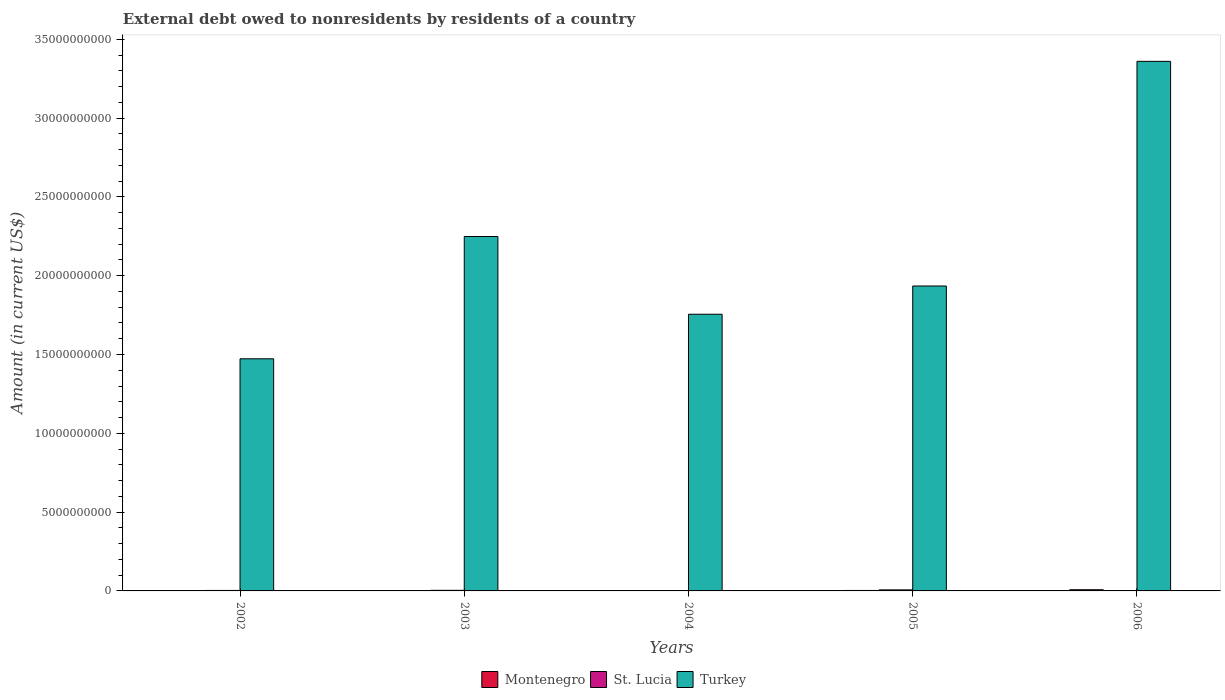How many different coloured bars are there?
Your answer should be compact. 3. How many groups of bars are there?
Offer a terse response. 5. What is the label of the 2nd group of bars from the left?
Make the answer very short. 2003. In how many cases, is the number of bars for a given year not equal to the number of legend labels?
Make the answer very short. 3. Across all years, what is the maximum external debt owed by residents in St. Lucia?
Make the answer very short. 6.54e+07. In which year was the external debt owed by residents in Turkey maximum?
Your response must be concise. 2006. What is the total external debt owed by residents in Montenegro in the graph?
Offer a terse response. 1.29e+08. What is the difference between the external debt owed by residents in St. Lucia in 2002 and that in 2003?
Provide a short and direct response. -7.80e+06. What is the difference between the external debt owed by residents in Montenegro in 2006 and the external debt owed by residents in Turkey in 2002?
Offer a terse response. -1.47e+1. What is the average external debt owed by residents in Montenegro per year?
Give a very brief answer. 2.58e+07. In the year 2004, what is the difference between the external debt owed by residents in St. Lucia and external debt owed by residents in Montenegro?
Provide a succinct answer. -4.16e+06. In how many years, is the external debt owed by residents in St. Lucia greater than 17000000000 US$?
Provide a short and direct response. 0. What is the ratio of the external debt owed by residents in Montenegro in 2004 to that in 2006?
Keep it short and to the point. 0.33. Is the external debt owed by residents in Montenegro in 2004 less than that in 2006?
Keep it short and to the point. Yes. What is the difference between the highest and the second highest external debt owed by residents in Montenegro?
Keep it short and to the point. 4.62e+07. What is the difference between the highest and the lowest external debt owed by residents in Montenegro?
Give a very brief answer. 7.52e+07. Is the sum of the external debt owed by residents in St. Lucia in 2002 and 2004 greater than the maximum external debt owed by residents in Montenegro across all years?
Offer a terse response. No. How many bars are there?
Your response must be concise. 12. How many years are there in the graph?
Provide a succinct answer. 5. What is the difference between two consecutive major ticks on the Y-axis?
Give a very brief answer. 5.00e+09. Are the values on the major ticks of Y-axis written in scientific E-notation?
Your answer should be compact. No. How are the legend labels stacked?
Offer a terse response. Horizontal. What is the title of the graph?
Keep it short and to the point. External debt owed to nonresidents by residents of a country. What is the Amount (in current US$) in St. Lucia in 2002?
Offer a very short reply. 3.02e+07. What is the Amount (in current US$) in Turkey in 2002?
Ensure brevity in your answer.  1.47e+1. What is the Amount (in current US$) of Montenegro in 2003?
Provide a short and direct response. 0. What is the Amount (in current US$) in St. Lucia in 2003?
Provide a short and direct response. 3.80e+07. What is the Amount (in current US$) in Turkey in 2003?
Offer a terse response. 2.25e+1. What is the Amount (in current US$) in Montenegro in 2004?
Ensure brevity in your answer.  2.50e+07. What is the Amount (in current US$) in St. Lucia in 2004?
Your answer should be compact. 2.08e+07. What is the Amount (in current US$) in Turkey in 2004?
Offer a terse response. 1.76e+1. What is the Amount (in current US$) of Montenegro in 2005?
Keep it short and to the point. 2.90e+07. What is the Amount (in current US$) in St. Lucia in 2005?
Provide a succinct answer. 6.54e+07. What is the Amount (in current US$) of Turkey in 2005?
Provide a succinct answer. 1.93e+1. What is the Amount (in current US$) of Montenegro in 2006?
Your answer should be very brief. 7.52e+07. What is the Amount (in current US$) of St. Lucia in 2006?
Keep it short and to the point. 0. What is the Amount (in current US$) in Turkey in 2006?
Provide a short and direct response. 3.36e+1. Across all years, what is the maximum Amount (in current US$) in Montenegro?
Provide a short and direct response. 7.52e+07. Across all years, what is the maximum Amount (in current US$) of St. Lucia?
Ensure brevity in your answer.  6.54e+07. Across all years, what is the maximum Amount (in current US$) of Turkey?
Your answer should be compact. 3.36e+1. Across all years, what is the minimum Amount (in current US$) of Montenegro?
Offer a terse response. 0. Across all years, what is the minimum Amount (in current US$) of Turkey?
Your response must be concise. 1.47e+1. What is the total Amount (in current US$) in Montenegro in the graph?
Your answer should be very brief. 1.29e+08. What is the total Amount (in current US$) of St. Lucia in the graph?
Your response must be concise. 1.54e+08. What is the total Amount (in current US$) of Turkey in the graph?
Make the answer very short. 1.08e+11. What is the difference between the Amount (in current US$) in St. Lucia in 2002 and that in 2003?
Your answer should be compact. -7.80e+06. What is the difference between the Amount (in current US$) in Turkey in 2002 and that in 2003?
Keep it short and to the point. -7.76e+09. What is the difference between the Amount (in current US$) of St. Lucia in 2002 and that in 2004?
Give a very brief answer. 9.38e+06. What is the difference between the Amount (in current US$) in Turkey in 2002 and that in 2004?
Ensure brevity in your answer.  -2.83e+09. What is the difference between the Amount (in current US$) of St. Lucia in 2002 and that in 2005?
Offer a very short reply. -3.52e+07. What is the difference between the Amount (in current US$) of Turkey in 2002 and that in 2005?
Make the answer very short. -4.62e+09. What is the difference between the Amount (in current US$) in Turkey in 2002 and that in 2006?
Your answer should be very brief. -1.89e+1. What is the difference between the Amount (in current US$) of St. Lucia in 2003 and that in 2004?
Provide a succinct answer. 1.72e+07. What is the difference between the Amount (in current US$) in Turkey in 2003 and that in 2004?
Your answer should be very brief. 4.93e+09. What is the difference between the Amount (in current US$) in St. Lucia in 2003 and that in 2005?
Your answer should be compact. -2.74e+07. What is the difference between the Amount (in current US$) in Turkey in 2003 and that in 2005?
Offer a very short reply. 3.14e+09. What is the difference between the Amount (in current US$) of Turkey in 2003 and that in 2006?
Offer a terse response. -1.11e+1. What is the difference between the Amount (in current US$) of Montenegro in 2004 and that in 2005?
Your answer should be compact. -4.05e+06. What is the difference between the Amount (in current US$) in St. Lucia in 2004 and that in 2005?
Offer a terse response. -4.46e+07. What is the difference between the Amount (in current US$) in Turkey in 2004 and that in 2005?
Your response must be concise. -1.79e+09. What is the difference between the Amount (in current US$) in Montenegro in 2004 and that in 2006?
Your answer should be compact. -5.02e+07. What is the difference between the Amount (in current US$) in Turkey in 2004 and that in 2006?
Keep it short and to the point. -1.60e+1. What is the difference between the Amount (in current US$) in Montenegro in 2005 and that in 2006?
Your answer should be compact. -4.62e+07. What is the difference between the Amount (in current US$) of Turkey in 2005 and that in 2006?
Make the answer very short. -1.43e+1. What is the difference between the Amount (in current US$) of St. Lucia in 2002 and the Amount (in current US$) of Turkey in 2003?
Provide a succinct answer. -2.25e+1. What is the difference between the Amount (in current US$) of St. Lucia in 2002 and the Amount (in current US$) of Turkey in 2004?
Provide a short and direct response. -1.75e+1. What is the difference between the Amount (in current US$) in St. Lucia in 2002 and the Amount (in current US$) in Turkey in 2005?
Your answer should be compact. -1.93e+1. What is the difference between the Amount (in current US$) in St. Lucia in 2002 and the Amount (in current US$) in Turkey in 2006?
Provide a short and direct response. -3.36e+1. What is the difference between the Amount (in current US$) in St. Lucia in 2003 and the Amount (in current US$) in Turkey in 2004?
Provide a succinct answer. -1.75e+1. What is the difference between the Amount (in current US$) of St. Lucia in 2003 and the Amount (in current US$) of Turkey in 2005?
Your answer should be very brief. -1.93e+1. What is the difference between the Amount (in current US$) of St. Lucia in 2003 and the Amount (in current US$) of Turkey in 2006?
Ensure brevity in your answer.  -3.36e+1. What is the difference between the Amount (in current US$) of Montenegro in 2004 and the Amount (in current US$) of St. Lucia in 2005?
Provide a short and direct response. -4.04e+07. What is the difference between the Amount (in current US$) of Montenegro in 2004 and the Amount (in current US$) of Turkey in 2005?
Your answer should be compact. -1.93e+1. What is the difference between the Amount (in current US$) in St. Lucia in 2004 and the Amount (in current US$) in Turkey in 2005?
Your response must be concise. -1.93e+1. What is the difference between the Amount (in current US$) in Montenegro in 2004 and the Amount (in current US$) in Turkey in 2006?
Make the answer very short. -3.36e+1. What is the difference between the Amount (in current US$) of St. Lucia in 2004 and the Amount (in current US$) of Turkey in 2006?
Provide a succinct answer. -3.36e+1. What is the difference between the Amount (in current US$) in Montenegro in 2005 and the Amount (in current US$) in Turkey in 2006?
Offer a very short reply. -3.36e+1. What is the difference between the Amount (in current US$) of St. Lucia in 2005 and the Amount (in current US$) of Turkey in 2006?
Offer a very short reply. -3.35e+1. What is the average Amount (in current US$) of Montenegro per year?
Your answer should be compact. 2.58e+07. What is the average Amount (in current US$) of St. Lucia per year?
Give a very brief answer. 3.09e+07. What is the average Amount (in current US$) in Turkey per year?
Your answer should be compact. 2.15e+1. In the year 2002, what is the difference between the Amount (in current US$) of St. Lucia and Amount (in current US$) of Turkey?
Ensure brevity in your answer.  -1.47e+1. In the year 2003, what is the difference between the Amount (in current US$) of St. Lucia and Amount (in current US$) of Turkey?
Offer a very short reply. -2.24e+1. In the year 2004, what is the difference between the Amount (in current US$) of Montenegro and Amount (in current US$) of St. Lucia?
Your response must be concise. 4.16e+06. In the year 2004, what is the difference between the Amount (in current US$) in Montenegro and Amount (in current US$) in Turkey?
Your answer should be compact. -1.75e+1. In the year 2004, what is the difference between the Amount (in current US$) in St. Lucia and Amount (in current US$) in Turkey?
Keep it short and to the point. -1.75e+1. In the year 2005, what is the difference between the Amount (in current US$) in Montenegro and Amount (in current US$) in St. Lucia?
Your answer should be very brief. -3.64e+07. In the year 2005, what is the difference between the Amount (in current US$) in Montenegro and Amount (in current US$) in Turkey?
Offer a very short reply. -1.93e+1. In the year 2005, what is the difference between the Amount (in current US$) in St. Lucia and Amount (in current US$) in Turkey?
Your answer should be compact. -1.93e+1. In the year 2006, what is the difference between the Amount (in current US$) in Montenegro and Amount (in current US$) in Turkey?
Ensure brevity in your answer.  -3.35e+1. What is the ratio of the Amount (in current US$) in St. Lucia in 2002 to that in 2003?
Your answer should be compact. 0.79. What is the ratio of the Amount (in current US$) of Turkey in 2002 to that in 2003?
Ensure brevity in your answer.  0.66. What is the ratio of the Amount (in current US$) of St. Lucia in 2002 to that in 2004?
Offer a very short reply. 1.45. What is the ratio of the Amount (in current US$) of Turkey in 2002 to that in 2004?
Give a very brief answer. 0.84. What is the ratio of the Amount (in current US$) of St. Lucia in 2002 to that in 2005?
Give a very brief answer. 0.46. What is the ratio of the Amount (in current US$) of Turkey in 2002 to that in 2005?
Your response must be concise. 0.76. What is the ratio of the Amount (in current US$) of Turkey in 2002 to that in 2006?
Your answer should be compact. 0.44. What is the ratio of the Amount (in current US$) of St. Lucia in 2003 to that in 2004?
Your answer should be compact. 1.83. What is the ratio of the Amount (in current US$) of Turkey in 2003 to that in 2004?
Offer a very short reply. 1.28. What is the ratio of the Amount (in current US$) of St. Lucia in 2003 to that in 2005?
Provide a short and direct response. 0.58. What is the ratio of the Amount (in current US$) of Turkey in 2003 to that in 2005?
Make the answer very short. 1.16. What is the ratio of the Amount (in current US$) of Turkey in 2003 to that in 2006?
Ensure brevity in your answer.  0.67. What is the ratio of the Amount (in current US$) in Montenegro in 2004 to that in 2005?
Ensure brevity in your answer.  0.86. What is the ratio of the Amount (in current US$) of St. Lucia in 2004 to that in 2005?
Your answer should be compact. 0.32. What is the ratio of the Amount (in current US$) in Turkey in 2004 to that in 2005?
Your answer should be compact. 0.91. What is the ratio of the Amount (in current US$) of Montenegro in 2004 to that in 2006?
Ensure brevity in your answer.  0.33. What is the ratio of the Amount (in current US$) in Turkey in 2004 to that in 2006?
Keep it short and to the point. 0.52. What is the ratio of the Amount (in current US$) of Montenegro in 2005 to that in 2006?
Provide a short and direct response. 0.39. What is the ratio of the Amount (in current US$) of Turkey in 2005 to that in 2006?
Ensure brevity in your answer.  0.58. What is the difference between the highest and the second highest Amount (in current US$) of Montenegro?
Make the answer very short. 4.62e+07. What is the difference between the highest and the second highest Amount (in current US$) in St. Lucia?
Provide a succinct answer. 2.74e+07. What is the difference between the highest and the second highest Amount (in current US$) of Turkey?
Your answer should be very brief. 1.11e+1. What is the difference between the highest and the lowest Amount (in current US$) in Montenegro?
Ensure brevity in your answer.  7.52e+07. What is the difference between the highest and the lowest Amount (in current US$) of St. Lucia?
Offer a very short reply. 6.54e+07. What is the difference between the highest and the lowest Amount (in current US$) in Turkey?
Your answer should be very brief. 1.89e+1. 